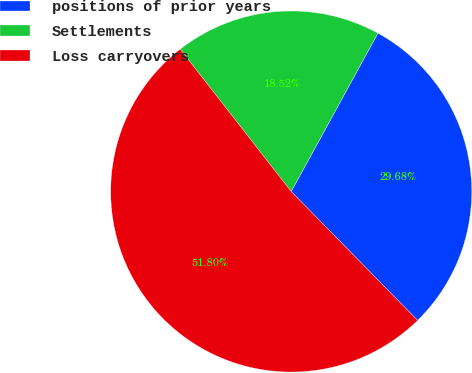<chart> <loc_0><loc_0><loc_500><loc_500><pie_chart><fcel>positions of prior years<fcel>Settlements<fcel>Loss carryovers<nl><fcel>29.68%<fcel>18.52%<fcel>51.8%<nl></chart> 